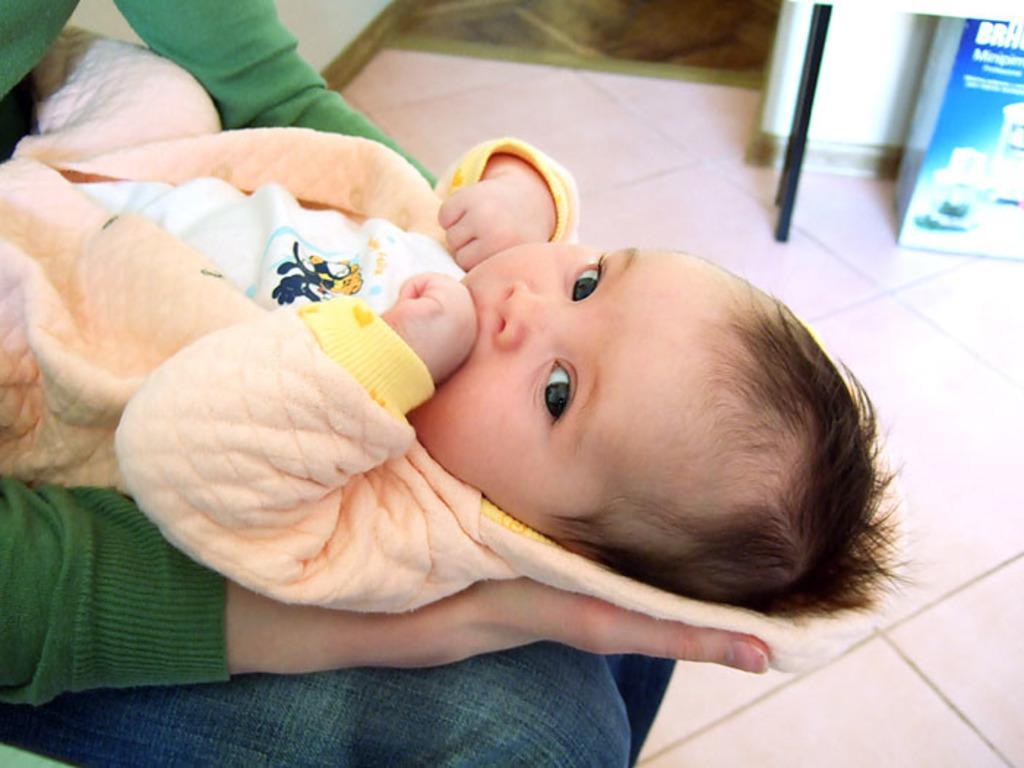Could you give a brief overview of what you see in this image? On the left of this picture we can see a person sitting and holding an Infant. In the background we can see the ground and the text and some depictions on an object and we can see some other objects. 